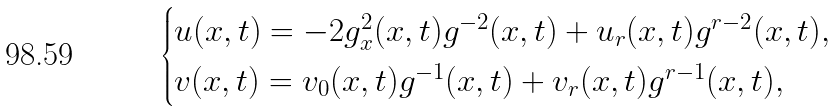<formula> <loc_0><loc_0><loc_500><loc_500>\begin{cases} u ( x , t ) = - 2 g _ { x } ^ { 2 } ( x , t ) g ^ { - 2 } ( x , t ) + u _ { r } ( x , t ) g ^ { r - 2 } ( x , t ) , \\ v ( x , t ) = v _ { 0 } ( x , t ) g ^ { - 1 } ( x , t ) + v _ { r } ( x , t ) g ^ { r - 1 } ( x , t ) , \end{cases}</formula> 